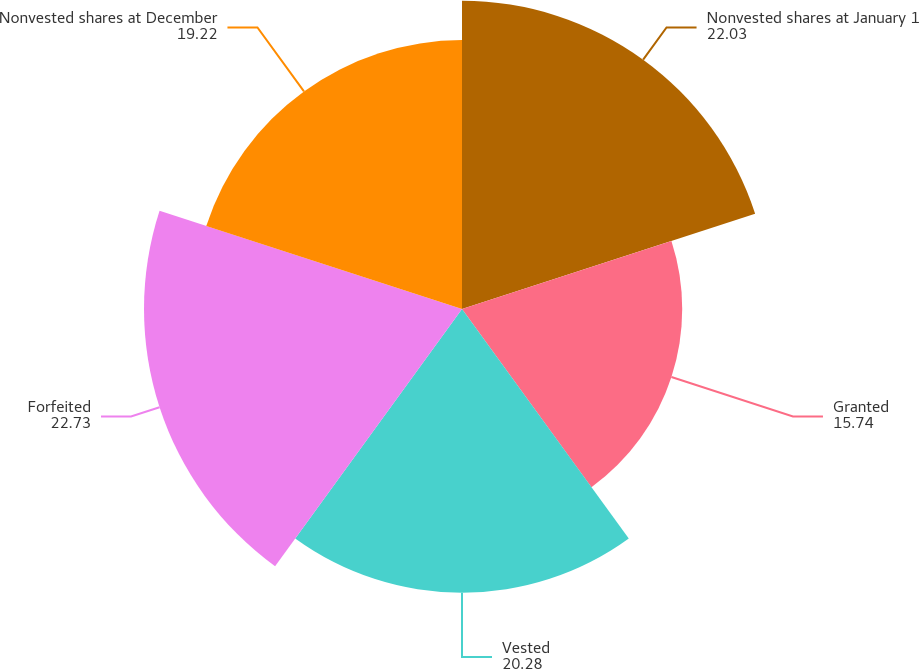<chart> <loc_0><loc_0><loc_500><loc_500><pie_chart><fcel>Nonvested shares at January 1<fcel>Granted<fcel>Vested<fcel>Forfeited<fcel>Nonvested shares at December<nl><fcel>22.03%<fcel>15.74%<fcel>20.28%<fcel>22.73%<fcel>19.22%<nl></chart> 